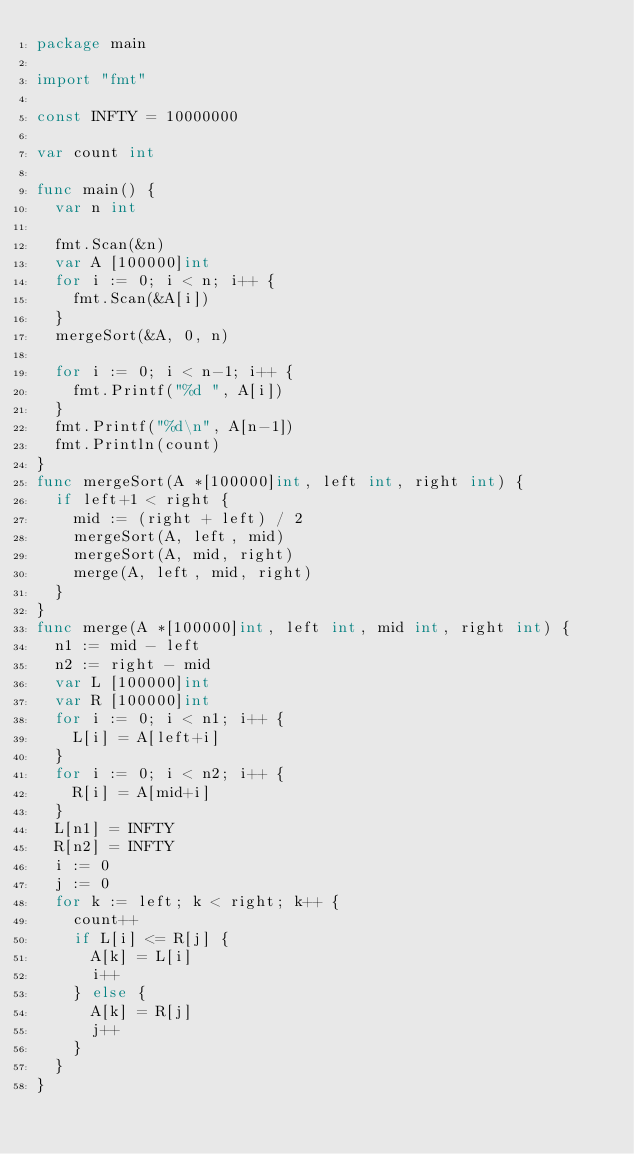<code> <loc_0><loc_0><loc_500><loc_500><_Go_>package main

import "fmt"

const INFTY = 10000000

var count int

func main() {
	var n int

	fmt.Scan(&n)
	var A [100000]int
	for i := 0; i < n; i++ {
		fmt.Scan(&A[i])
	}
	mergeSort(&A, 0, n)

	for i := 0; i < n-1; i++ {
		fmt.Printf("%d ", A[i])
	}
	fmt.Printf("%d\n", A[n-1])
	fmt.Println(count)
}
func mergeSort(A *[100000]int, left int, right int) {
	if left+1 < right {
		mid := (right + left) / 2
		mergeSort(A, left, mid)
		mergeSort(A, mid, right)
		merge(A, left, mid, right)
	}
}
func merge(A *[100000]int, left int, mid int, right int) {
	n1 := mid - left
	n2 := right - mid
	var L [100000]int
	var R [100000]int
	for i := 0; i < n1; i++ {
		L[i] = A[left+i]
	}
	for i := 0; i < n2; i++ {
		R[i] = A[mid+i]
	}
	L[n1] = INFTY
	R[n2] = INFTY
	i := 0
	j := 0
	for k := left; k < right; k++ {
		count++
		if L[i] <= R[j] {
			A[k] = L[i]
			i++
		} else {
			A[k] = R[j]
			j++
		}
	}
}

</code> 